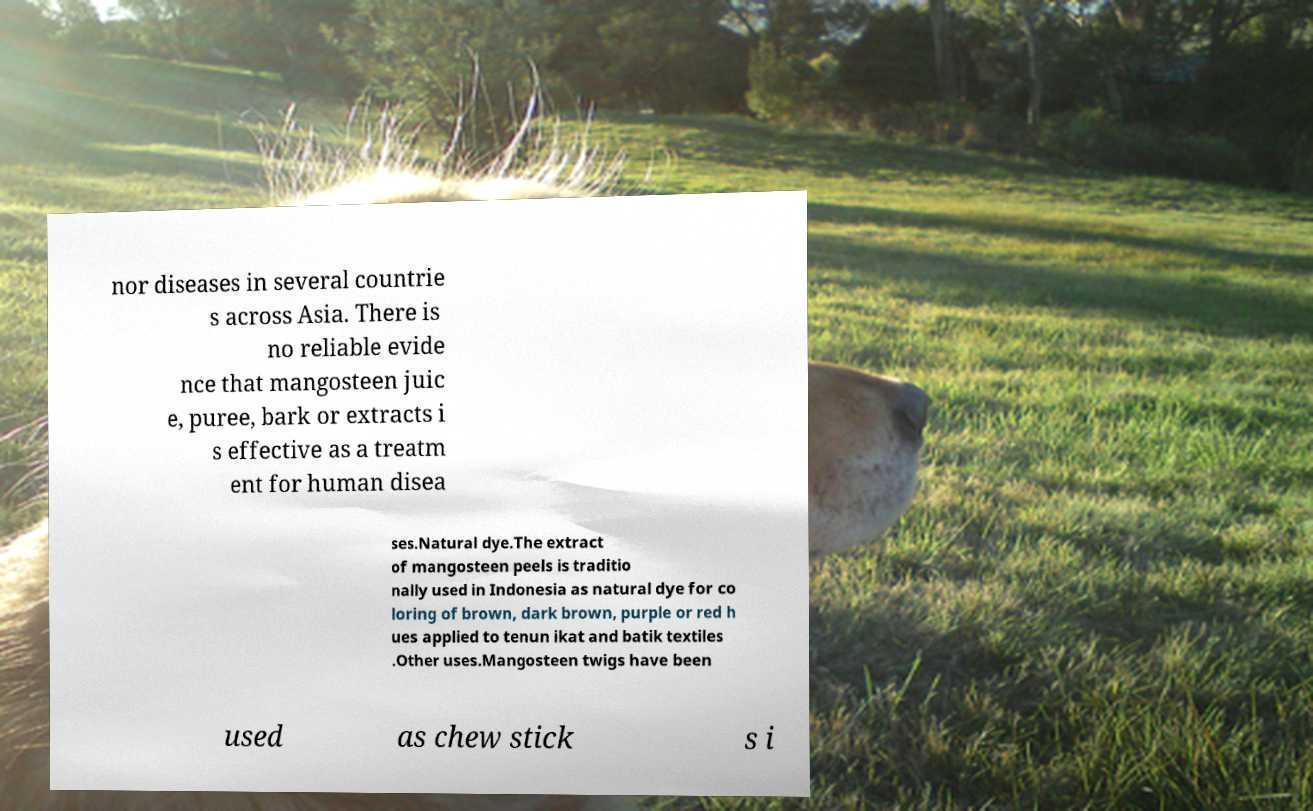For documentation purposes, I need the text within this image transcribed. Could you provide that? nor diseases in several countrie s across Asia. There is no reliable evide nce that mangosteen juic e, puree, bark or extracts i s effective as a treatm ent for human disea ses.Natural dye.The extract of mangosteen peels is traditio nally used in Indonesia as natural dye for co loring of brown, dark brown, purple or red h ues applied to tenun ikat and batik textiles .Other uses.Mangosteen twigs have been used as chew stick s i 